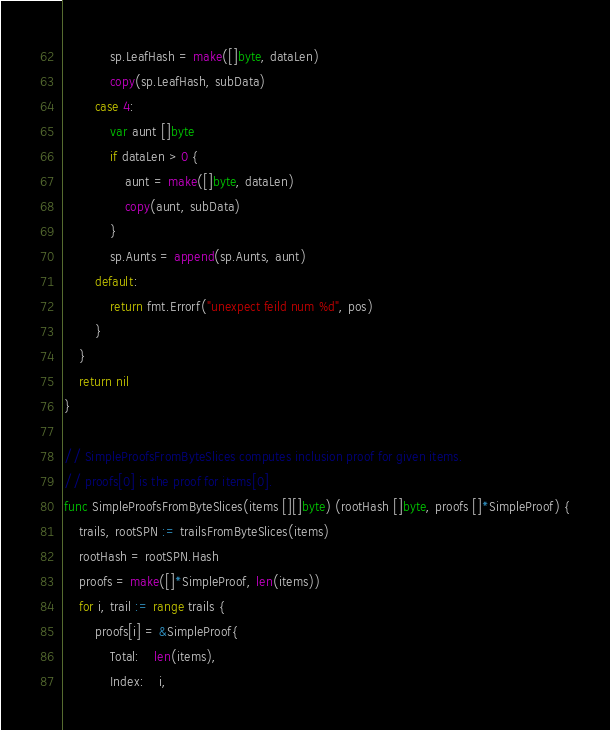<code> <loc_0><loc_0><loc_500><loc_500><_Go_>			sp.LeafHash = make([]byte, dataLen)
			copy(sp.LeafHash, subData)
		case 4:
			var aunt []byte
			if dataLen > 0 {
				aunt = make([]byte, dataLen)
				copy(aunt, subData)
			}
			sp.Aunts = append(sp.Aunts, aunt)
		default:
			return fmt.Errorf("unexpect feild num %d", pos)
		}
	}
	return nil
}

// SimpleProofsFromByteSlices computes inclusion proof for given items.
// proofs[0] is the proof for items[0].
func SimpleProofsFromByteSlices(items [][]byte) (rootHash []byte, proofs []*SimpleProof) {
	trails, rootSPN := trailsFromByteSlices(items)
	rootHash = rootSPN.Hash
	proofs = make([]*SimpleProof, len(items))
	for i, trail := range trails {
		proofs[i] = &SimpleProof{
			Total:    len(items),
			Index:    i,</code> 